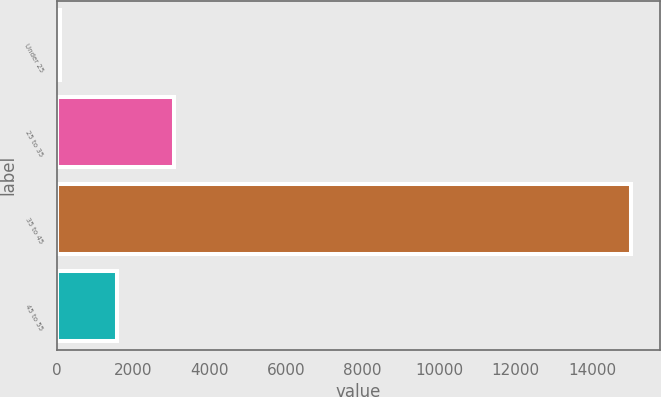Convert chart to OTSL. <chart><loc_0><loc_0><loc_500><loc_500><bar_chart><fcel>Under 25<fcel>25 to 35<fcel>35 to 45<fcel>45 to 55<nl><fcel>73<fcel>3062.4<fcel>15020<fcel>1567.7<nl></chart> 